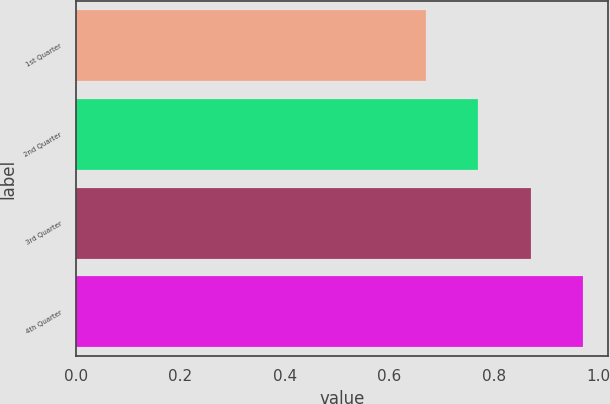Convert chart to OTSL. <chart><loc_0><loc_0><loc_500><loc_500><bar_chart><fcel>1st Quarter<fcel>2nd Quarter<fcel>3rd Quarter<fcel>4th Quarter<nl><fcel>0.67<fcel>0.77<fcel>0.87<fcel>0.97<nl></chart> 